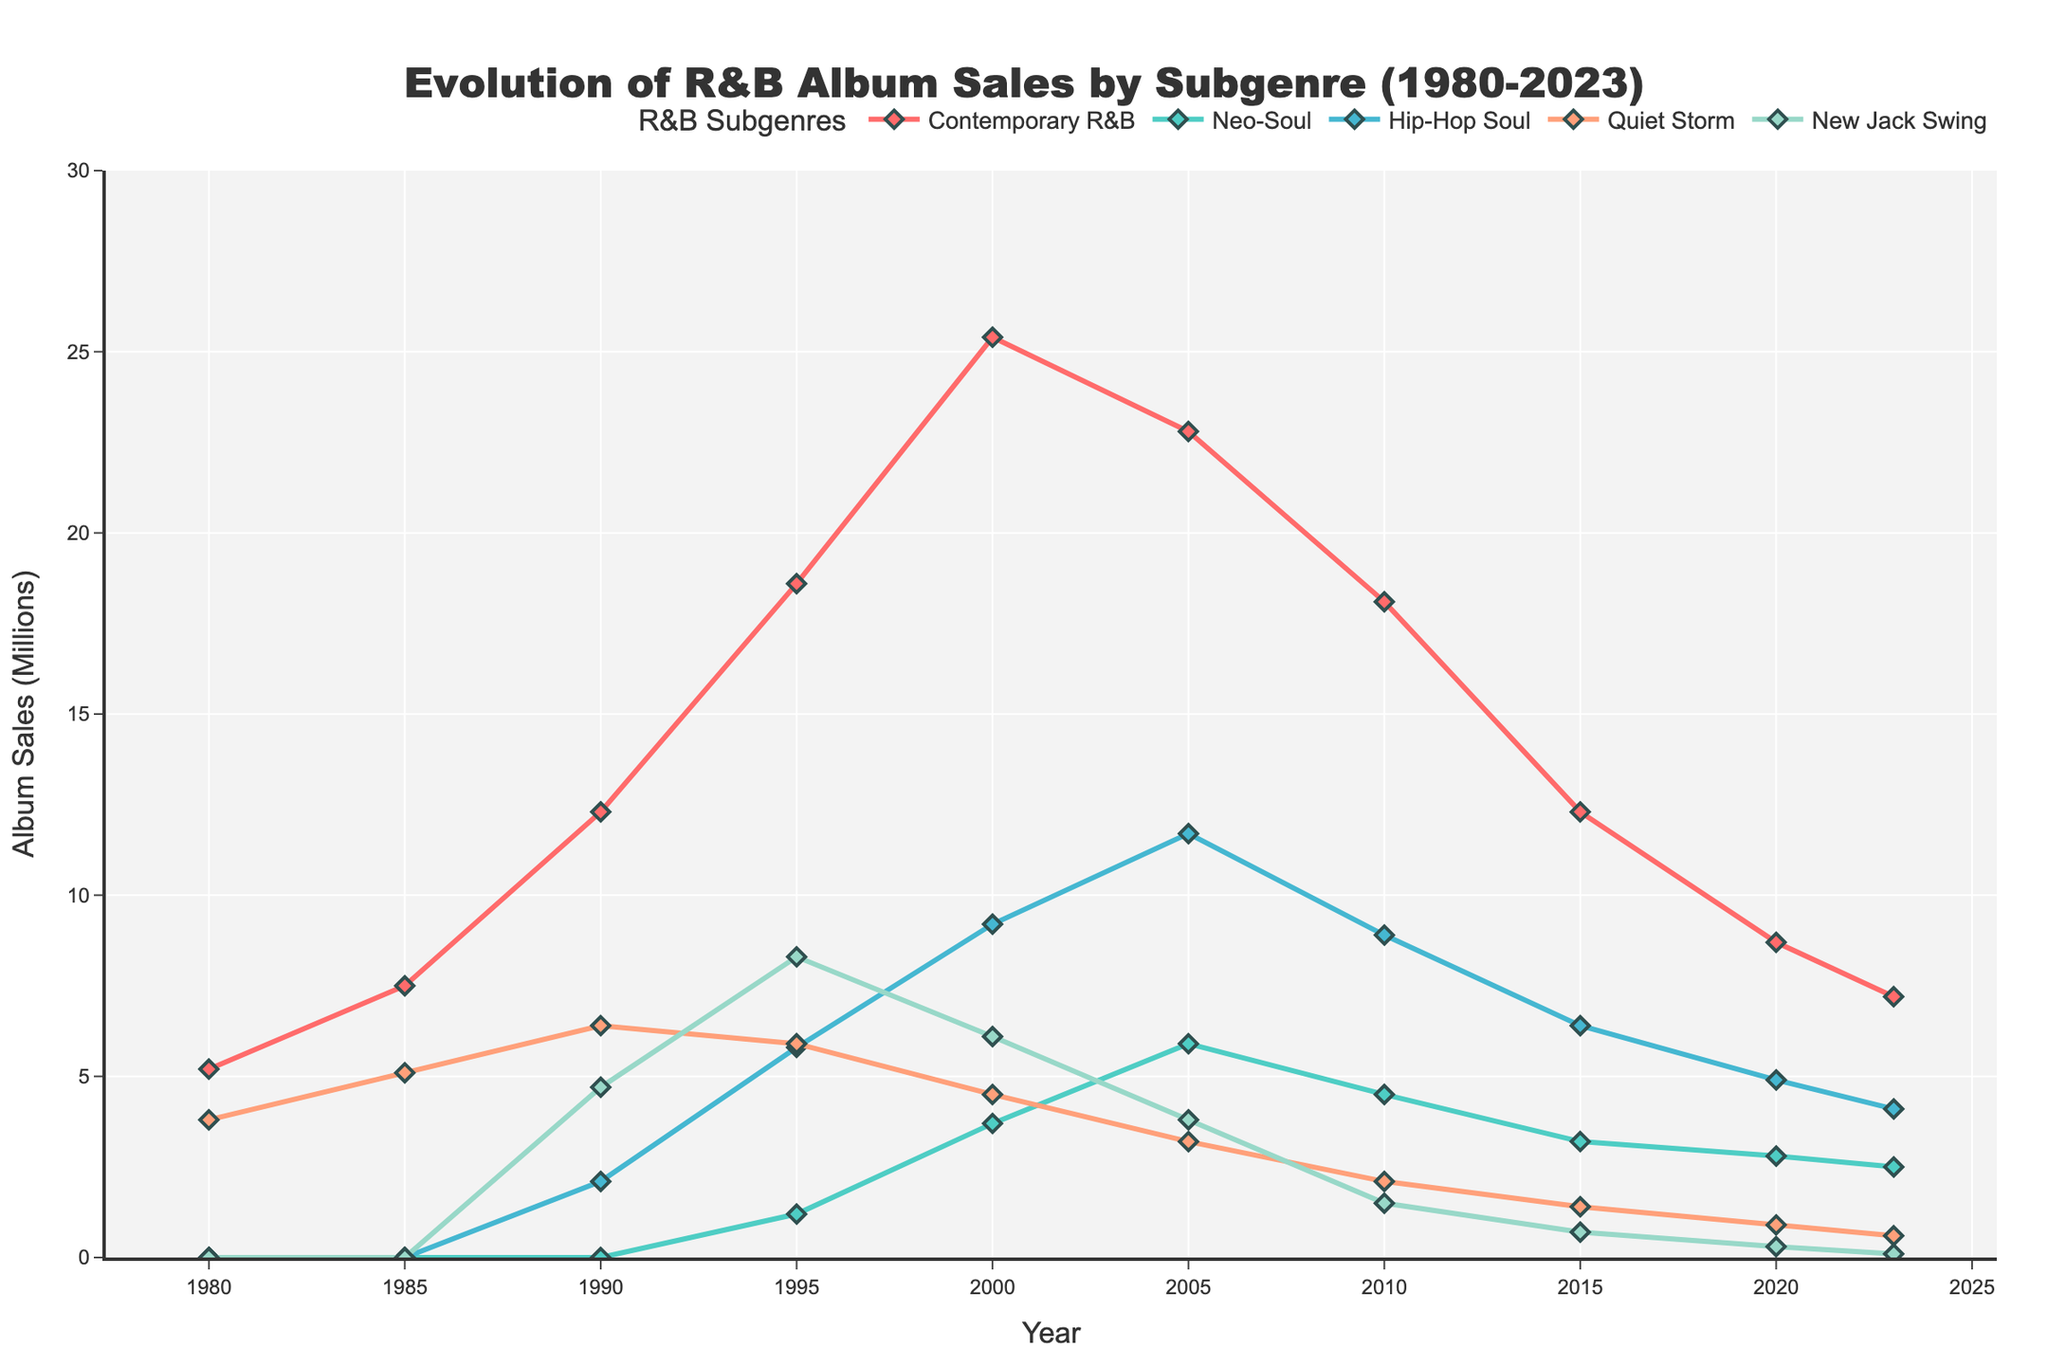Which subgenre saw the highest peak in album sales? By looking at the highest point on the line chart for each subgenre, we observe that Contemporary R&B reached a peak of 25.4 million in 2000, the highest among all the subgenres.
Answer: Contemporary R&B How did Neo-Soul album sales change from 2000 to 2023? Neo-Soul sales decreased from 3.7 million in 2000 to 2.5 million in 2023.
Answer: Decreased Which subgenre had the smallest decline in album sales from 1995 to 2023? We look at the change in album sales for each subgenre from 1995 to 2023 and find that Hip-Hop Soul had a decrease from 5.8 to 4.1 million, a decline of 1.7 million, which is the smallest decline.
Answer: Hip-Hop Soul During which time period did Contemporary R&B see its most significant growth? By observing the slope of the Contemporary R&B line, the period between 1985 and 2000 shows the most significant rise, from 7.5 to 25.4 million.
Answer: 1985 to 2000 Which two subgenres' album sales were closest to each other in 2010? By comparing the values for each subgenre in 2010, Neo-Soul and Hip-Hop Soul have values of 4.5 and 8.9 million respectively, which are closest to each other.
Answer: Neo-Soul and Hip-Hop Soul How much did New Jack Swing album sales increase from 1990 to 1995? New Jack Swing sales increased from 4.7 million to 8.3 million. The increase is calculated as 8.3 - 4.7 = 3.6 million.
Answer: 3.6 million What were the album sales of Quiet Storm in 2005 compared to 2023? Quiet Storm sales in 2005 were 3.2 million, and 0.6 million in 2023. To compare, we note the difference, which is 2.6 million.
Answer: 2.6 million less Did any subgenre have a constant increase or decrease throughout the period? By examining the trend lines of all subgenres, none of them exhibit a constant increase or decrease. All show periods of both rise and fall.
Answer: No Which subgenre had higher album sales, Hip-Hop Soul in 2000 or Quiet Storm in 1990? We compare Hip-Hop Soul sales in 2000 (9.2 million) and Quiet Storm sales in 1990 (6.4 million). Hip-Hop Soul had higher sales.
Answer: Hip-Hop Soul in 2000 